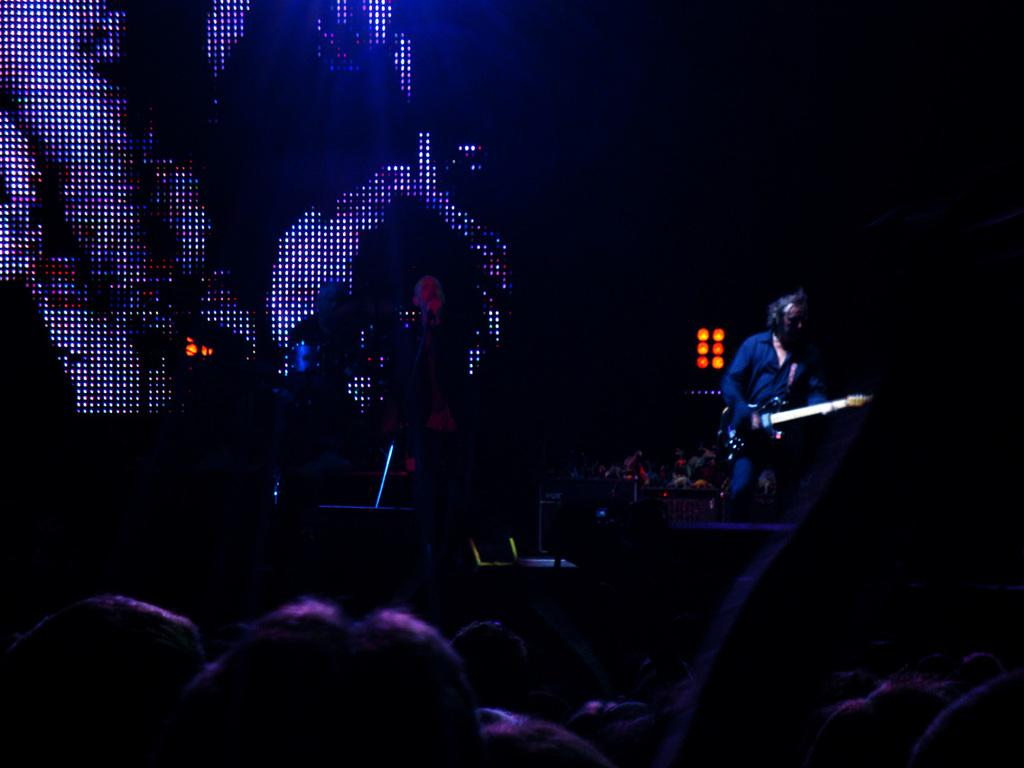What is the man in the image doing? The man is playing a guitar in the image. What else can be seen in the image besides the man playing the guitar? There are lights and people visible in the image. Where is the playground located in the image? There is no playground present in the image. Can you provide an example of a thrilling activity happening in the image? The image does not depict any thrilling activities; it simply shows a man playing a guitar. 